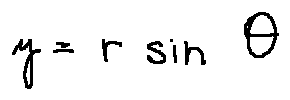<formula> <loc_0><loc_0><loc_500><loc_500>y = r \sin \theta</formula> 